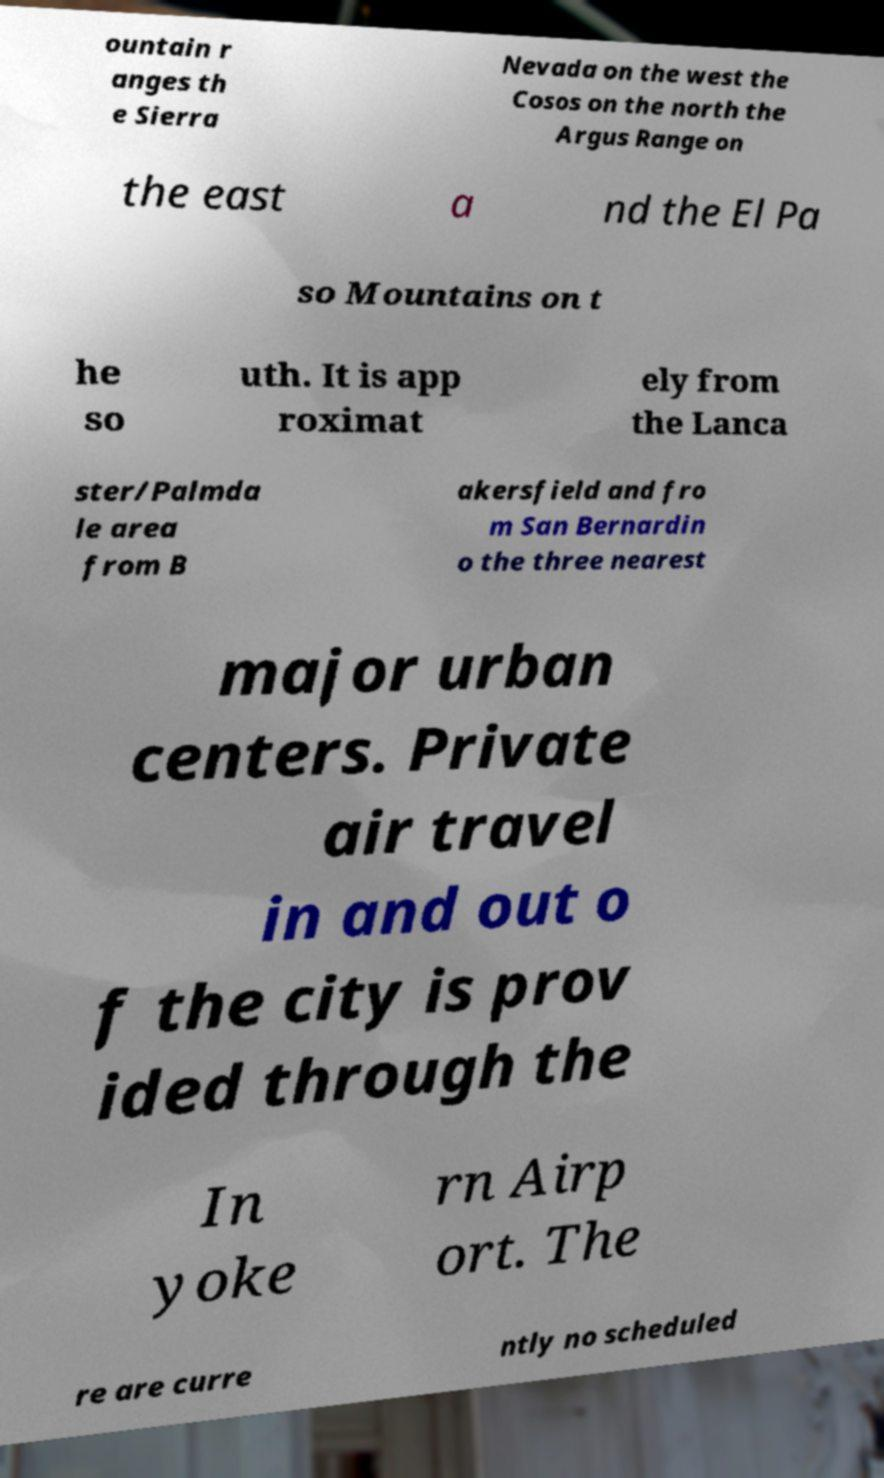Please read and relay the text visible in this image. What does it say? ountain r anges th e Sierra Nevada on the west the Cosos on the north the Argus Range on the east a nd the El Pa so Mountains on t he so uth. It is app roximat ely from the Lanca ster/Palmda le area from B akersfield and fro m San Bernardin o the three nearest major urban centers. Private air travel in and out o f the city is prov ided through the In yoke rn Airp ort. The re are curre ntly no scheduled 